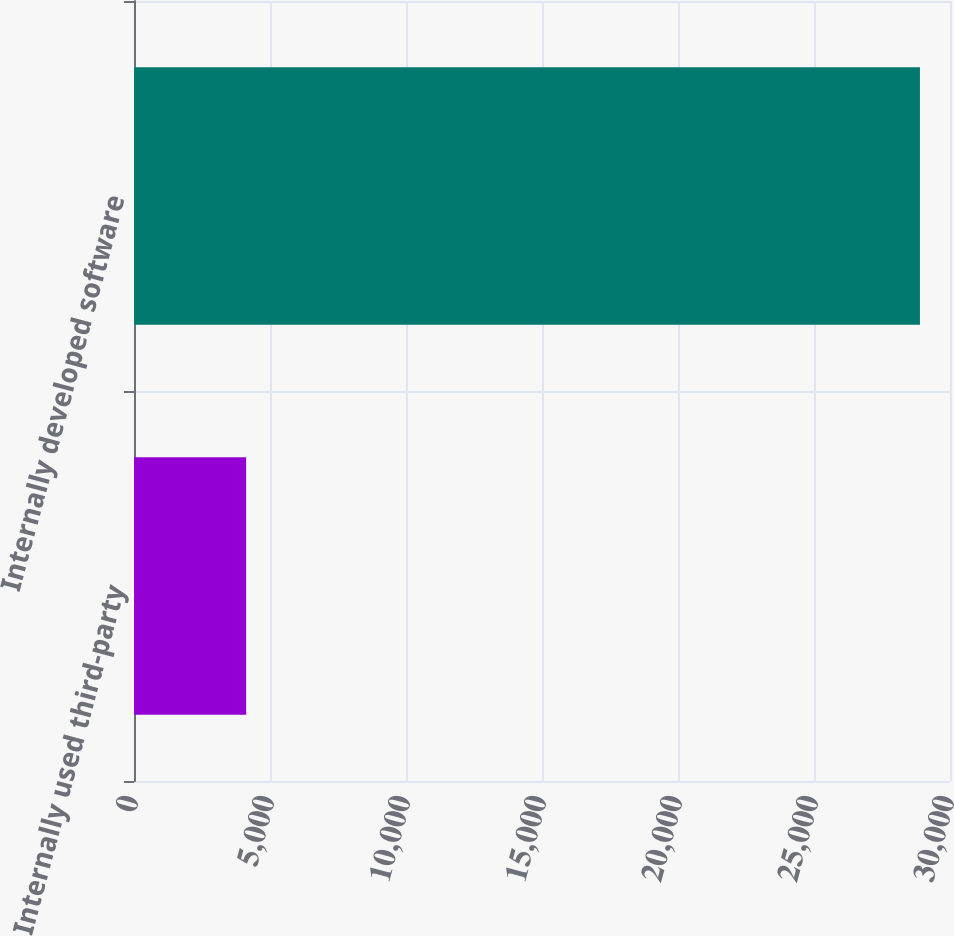Convert chart. <chart><loc_0><loc_0><loc_500><loc_500><bar_chart><fcel>Internally used third-party<fcel>Internally developed software<nl><fcel>4123<fcel>28895<nl></chart> 